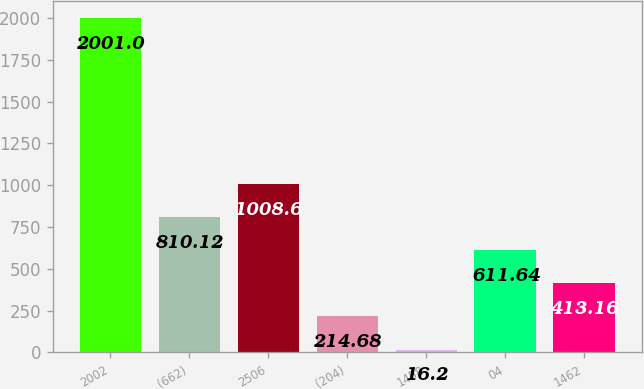Convert chart to OTSL. <chart><loc_0><loc_0><loc_500><loc_500><bar_chart><fcel>2002<fcel>(662)<fcel>2506<fcel>(204)<fcel>1458<fcel>04<fcel>1462<nl><fcel>2001<fcel>810.12<fcel>1008.6<fcel>214.68<fcel>16.2<fcel>611.64<fcel>413.16<nl></chart> 